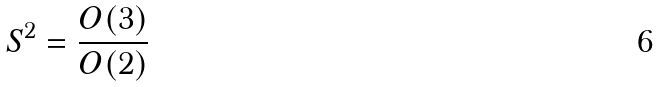<formula> <loc_0><loc_0><loc_500><loc_500>S ^ { 2 } = \frac { O ( 3 ) } { O ( 2 ) }</formula> 